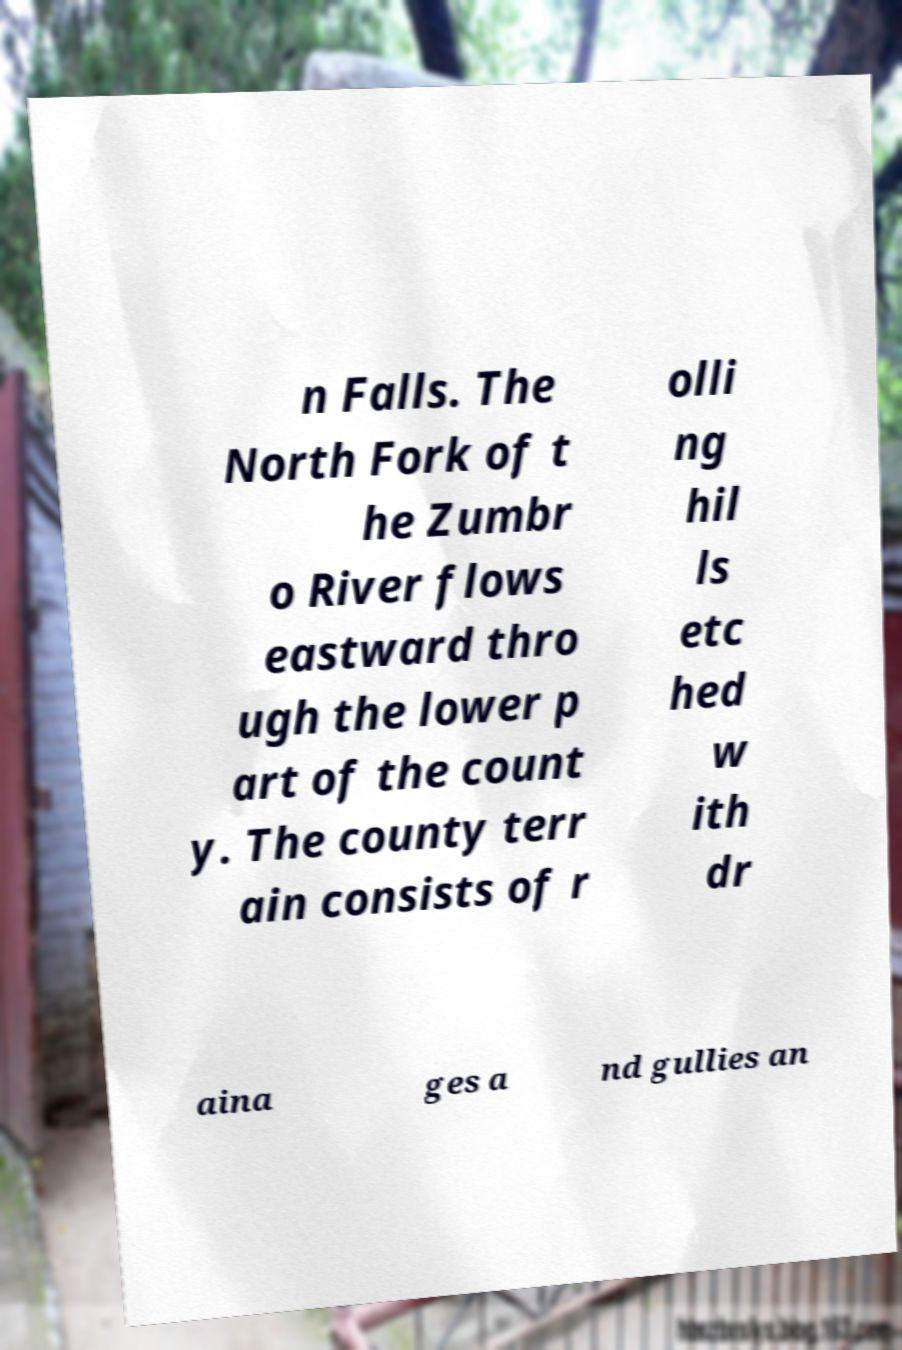Can you read and provide the text displayed in the image?This photo seems to have some interesting text. Can you extract and type it out for me? n Falls. The North Fork of t he Zumbr o River flows eastward thro ugh the lower p art of the count y. The county terr ain consists of r olli ng hil ls etc hed w ith dr aina ges a nd gullies an 